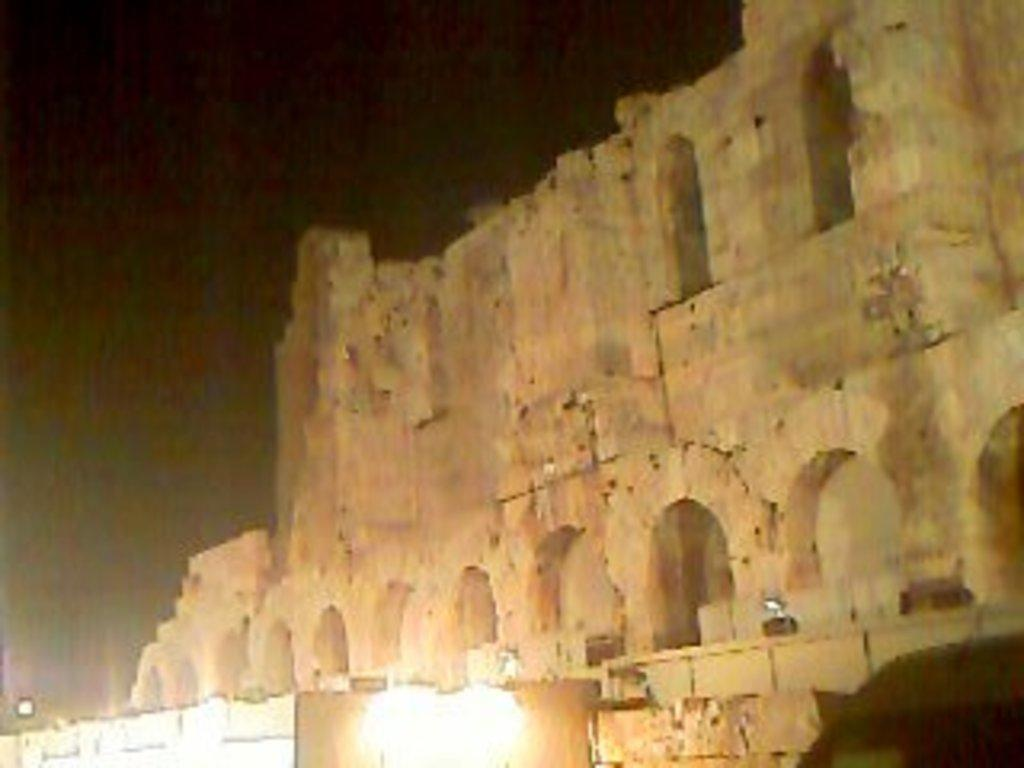What type of structure is the main subject of the picture? There is a fort in the picture. What is a feature of the fort? There is a wall associated with the fort. What can be seen attached to the fort? Lights are attached to the fort. How would you describe the sky in the background of the picture? The sky in the background appears dark. What type of milk is being poured into the waste container in the image? There is no milk or waste container present in the image; it features a fort with lights and a dark sky in the background. 